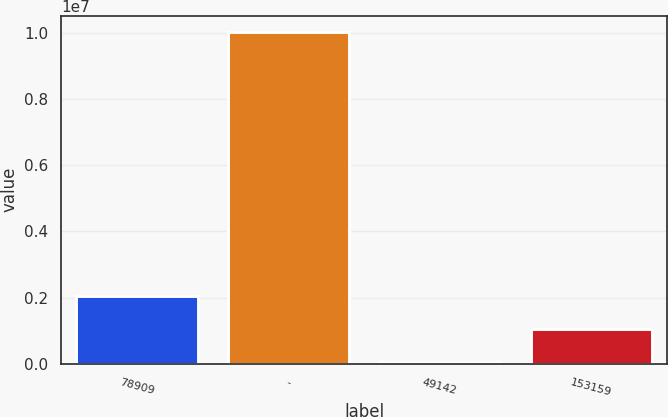<chart> <loc_0><loc_0><loc_500><loc_500><bar_chart><fcel>78909<fcel>-<fcel>49142<fcel>153159<nl><fcel>2.05443e+06<fcel>1.00219e+07<fcel>62555<fcel>1.05849e+06<nl></chart> 